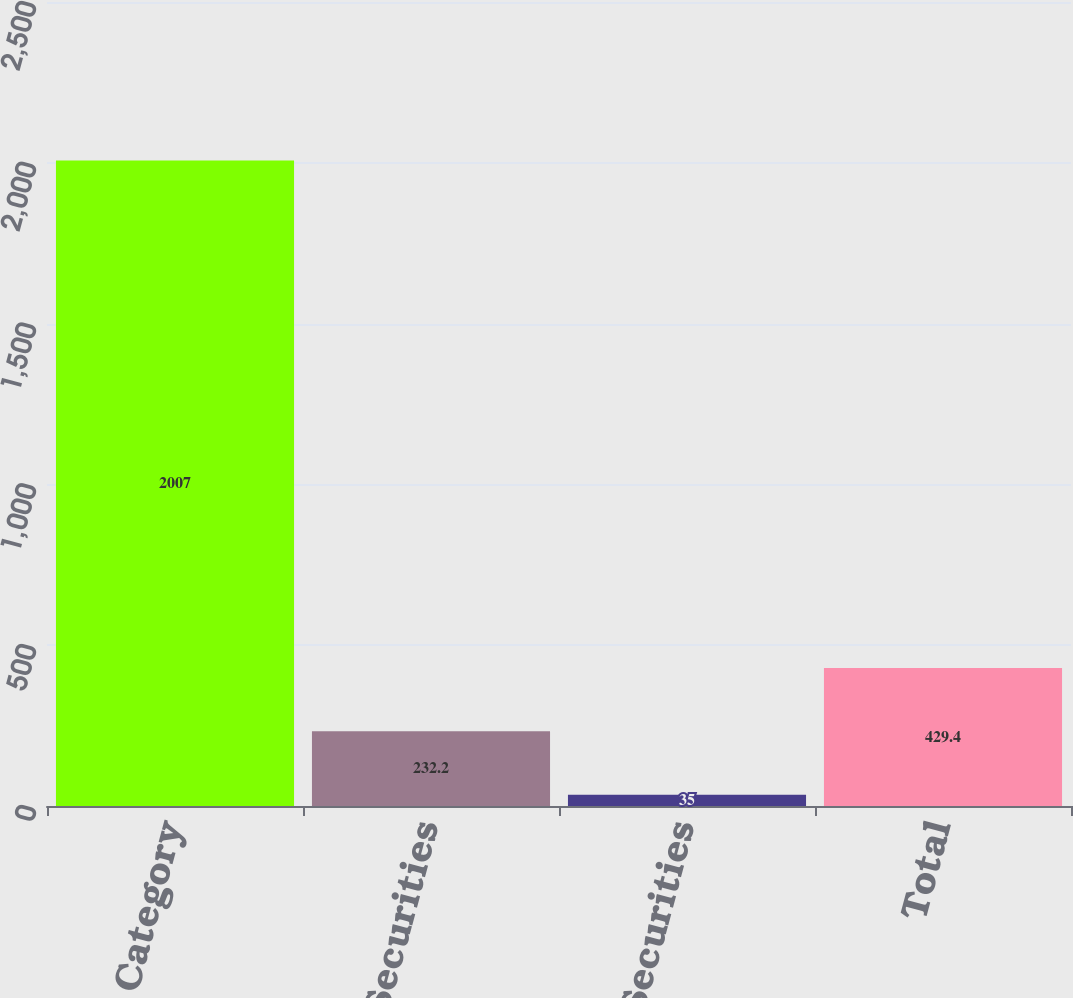Convert chart to OTSL. <chart><loc_0><loc_0><loc_500><loc_500><bar_chart><fcel>Asset Category<fcel>Equity Securities<fcel>Debt Securities<fcel>Total<nl><fcel>2007<fcel>232.2<fcel>35<fcel>429.4<nl></chart> 